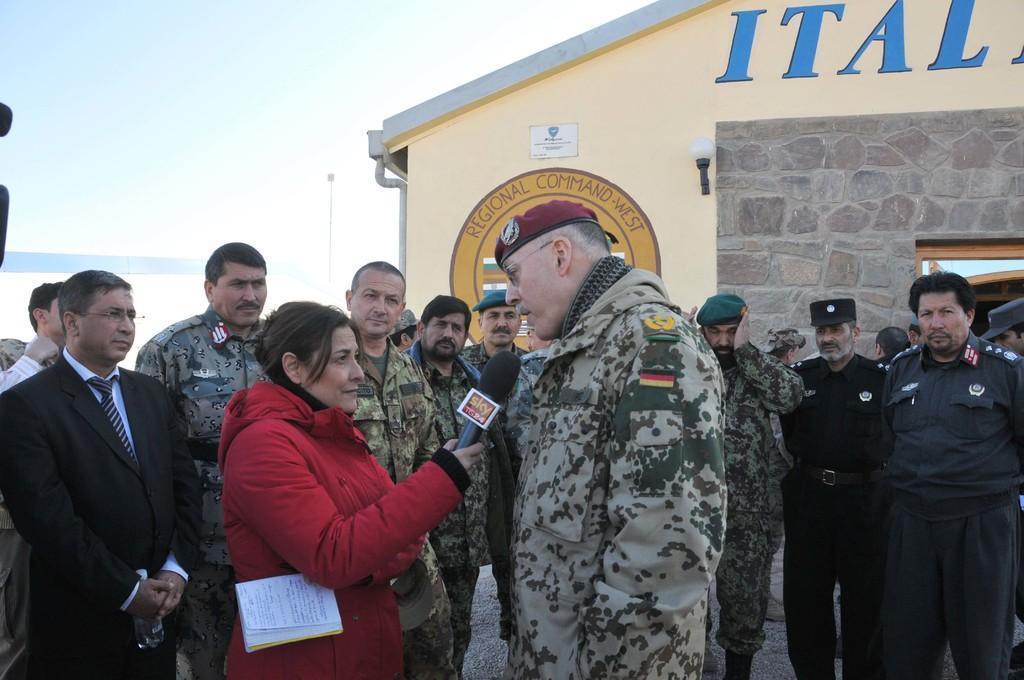Describe this image in one or two sentences. In this picture we can see the military general standing in the front and beside there is a lady reporter, taking the interview with microphone. Behind there are some army persons standing and looking to him. In the background we can see granite wall and yellow shade house. 